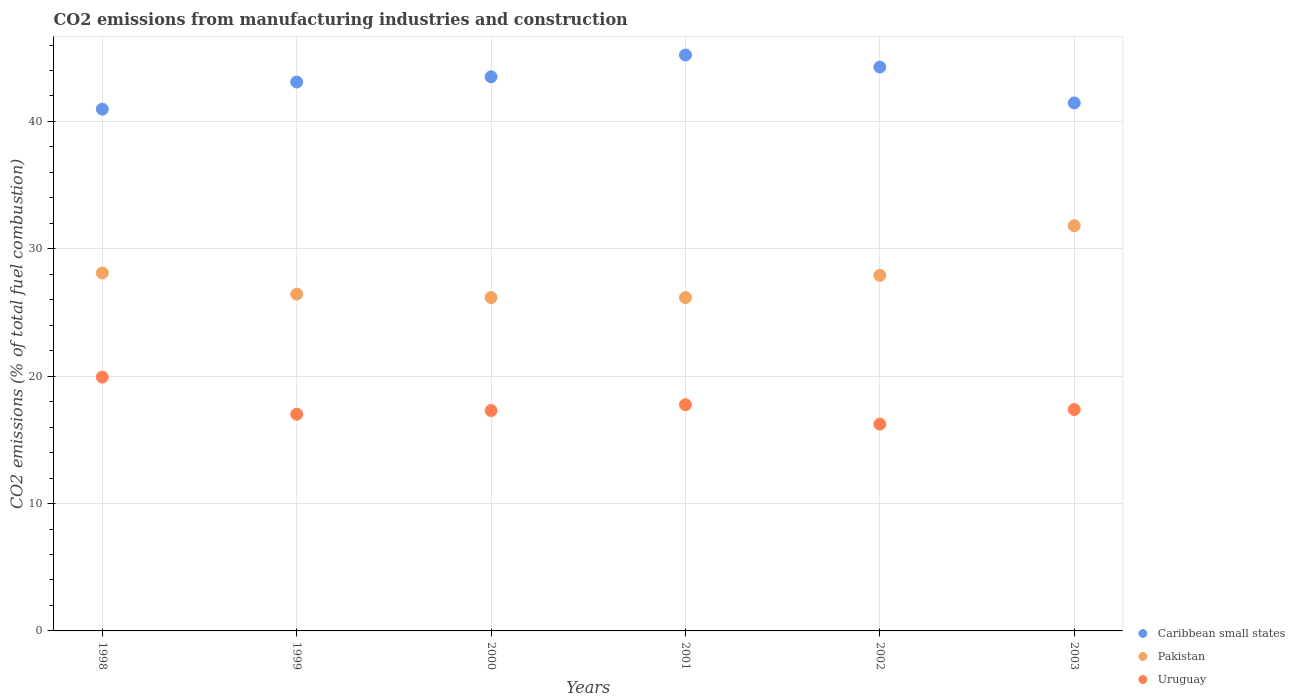Is the number of dotlines equal to the number of legend labels?
Offer a terse response. Yes. What is the amount of CO2 emitted in Caribbean small states in 2001?
Keep it short and to the point. 45.21. Across all years, what is the maximum amount of CO2 emitted in Uruguay?
Your response must be concise. 19.93. Across all years, what is the minimum amount of CO2 emitted in Caribbean small states?
Your answer should be compact. 40.97. What is the total amount of CO2 emitted in Uruguay in the graph?
Keep it short and to the point. 105.62. What is the difference between the amount of CO2 emitted in Uruguay in 2000 and that in 2001?
Your answer should be very brief. -0.46. What is the difference between the amount of CO2 emitted in Pakistan in 2002 and the amount of CO2 emitted in Uruguay in 2000?
Make the answer very short. 10.61. What is the average amount of CO2 emitted in Pakistan per year?
Make the answer very short. 27.77. In the year 2001, what is the difference between the amount of CO2 emitted in Uruguay and amount of CO2 emitted in Pakistan?
Your response must be concise. -8.41. What is the ratio of the amount of CO2 emitted in Pakistan in 1998 to that in 2000?
Ensure brevity in your answer.  1.07. Is the difference between the amount of CO2 emitted in Uruguay in 1999 and 2002 greater than the difference between the amount of CO2 emitted in Pakistan in 1999 and 2002?
Your answer should be compact. Yes. What is the difference between the highest and the second highest amount of CO2 emitted in Pakistan?
Provide a short and direct response. 3.71. What is the difference between the highest and the lowest amount of CO2 emitted in Uruguay?
Keep it short and to the point. 3.69. Is the sum of the amount of CO2 emitted in Pakistan in 1998 and 2001 greater than the maximum amount of CO2 emitted in Uruguay across all years?
Your answer should be very brief. Yes. Is it the case that in every year, the sum of the amount of CO2 emitted in Caribbean small states and amount of CO2 emitted in Uruguay  is greater than the amount of CO2 emitted in Pakistan?
Offer a terse response. Yes. Does the amount of CO2 emitted in Uruguay monotonically increase over the years?
Provide a short and direct response. No. Is the amount of CO2 emitted in Caribbean small states strictly greater than the amount of CO2 emitted in Pakistan over the years?
Give a very brief answer. Yes. How many dotlines are there?
Your answer should be compact. 3. How many years are there in the graph?
Give a very brief answer. 6. Does the graph contain any zero values?
Ensure brevity in your answer.  No. Does the graph contain grids?
Provide a short and direct response. Yes. Where does the legend appear in the graph?
Make the answer very short. Bottom right. How many legend labels are there?
Your response must be concise. 3. How are the legend labels stacked?
Make the answer very short. Vertical. What is the title of the graph?
Provide a short and direct response. CO2 emissions from manufacturing industries and construction. Does "Palau" appear as one of the legend labels in the graph?
Provide a short and direct response. No. What is the label or title of the Y-axis?
Provide a short and direct response. CO2 emissions (% of total fuel combustion). What is the CO2 emissions (% of total fuel combustion) in Caribbean small states in 1998?
Offer a terse response. 40.97. What is the CO2 emissions (% of total fuel combustion) in Pakistan in 1998?
Keep it short and to the point. 28.1. What is the CO2 emissions (% of total fuel combustion) in Uruguay in 1998?
Give a very brief answer. 19.93. What is the CO2 emissions (% of total fuel combustion) in Caribbean small states in 1999?
Make the answer very short. 43.1. What is the CO2 emissions (% of total fuel combustion) of Pakistan in 1999?
Your answer should be very brief. 26.44. What is the CO2 emissions (% of total fuel combustion) of Uruguay in 1999?
Provide a short and direct response. 17.01. What is the CO2 emissions (% of total fuel combustion) in Caribbean small states in 2000?
Keep it short and to the point. 43.5. What is the CO2 emissions (% of total fuel combustion) of Pakistan in 2000?
Provide a succinct answer. 26.17. What is the CO2 emissions (% of total fuel combustion) of Uruguay in 2000?
Your response must be concise. 17.3. What is the CO2 emissions (% of total fuel combustion) of Caribbean small states in 2001?
Your answer should be compact. 45.21. What is the CO2 emissions (% of total fuel combustion) of Pakistan in 2001?
Your response must be concise. 26.17. What is the CO2 emissions (% of total fuel combustion) of Uruguay in 2001?
Give a very brief answer. 17.76. What is the CO2 emissions (% of total fuel combustion) in Caribbean small states in 2002?
Make the answer very short. 44.27. What is the CO2 emissions (% of total fuel combustion) in Pakistan in 2002?
Offer a terse response. 27.91. What is the CO2 emissions (% of total fuel combustion) in Uruguay in 2002?
Provide a short and direct response. 16.24. What is the CO2 emissions (% of total fuel combustion) in Caribbean small states in 2003?
Offer a terse response. 41.45. What is the CO2 emissions (% of total fuel combustion) in Pakistan in 2003?
Your response must be concise. 31.81. What is the CO2 emissions (% of total fuel combustion) in Uruguay in 2003?
Give a very brief answer. 17.38. Across all years, what is the maximum CO2 emissions (% of total fuel combustion) of Caribbean small states?
Your response must be concise. 45.21. Across all years, what is the maximum CO2 emissions (% of total fuel combustion) of Pakistan?
Your answer should be compact. 31.81. Across all years, what is the maximum CO2 emissions (% of total fuel combustion) in Uruguay?
Give a very brief answer. 19.93. Across all years, what is the minimum CO2 emissions (% of total fuel combustion) in Caribbean small states?
Offer a very short reply. 40.97. Across all years, what is the minimum CO2 emissions (% of total fuel combustion) of Pakistan?
Give a very brief answer. 26.17. Across all years, what is the minimum CO2 emissions (% of total fuel combustion) of Uruguay?
Your answer should be compact. 16.24. What is the total CO2 emissions (% of total fuel combustion) of Caribbean small states in the graph?
Give a very brief answer. 258.5. What is the total CO2 emissions (% of total fuel combustion) in Pakistan in the graph?
Your answer should be compact. 166.62. What is the total CO2 emissions (% of total fuel combustion) of Uruguay in the graph?
Provide a succinct answer. 105.62. What is the difference between the CO2 emissions (% of total fuel combustion) in Caribbean small states in 1998 and that in 1999?
Ensure brevity in your answer.  -2.13. What is the difference between the CO2 emissions (% of total fuel combustion) of Pakistan in 1998 and that in 1999?
Provide a short and direct response. 1.66. What is the difference between the CO2 emissions (% of total fuel combustion) in Uruguay in 1998 and that in 1999?
Offer a terse response. 2.91. What is the difference between the CO2 emissions (% of total fuel combustion) of Caribbean small states in 1998 and that in 2000?
Your answer should be very brief. -2.54. What is the difference between the CO2 emissions (% of total fuel combustion) in Pakistan in 1998 and that in 2000?
Provide a short and direct response. 1.93. What is the difference between the CO2 emissions (% of total fuel combustion) in Uruguay in 1998 and that in 2000?
Provide a succinct answer. 2.63. What is the difference between the CO2 emissions (% of total fuel combustion) of Caribbean small states in 1998 and that in 2001?
Your response must be concise. -4.25. What is the difference between the CO2 emissions (% of total fuel combustion) of Pakistan in 1998 and that in 2001?
Ensure brevity in your answer.  1.93. What is the difference between the CO2 emissions (% of total fuel combustion) in Uruguay in 1998 and that in 2001?
Give a very brief answer. 2.17. What is the difference between the CO2 emissions (% of total fuel combustion) in Caribbean small states in 1998 and that in 2002?
Keep it short and to the point. -3.31. What is the difference between the CO2 emissions (% of total fuel combustion) in Pakistan in 1998 and that in 2002?
Your answer should be compact. 0.19. What is the difference between the CO2 emissions (% of total fuel combustion) of Uruguay in 1998 and that in 2002?
Your answer should be compact. 3.69. What is the difference between the CO2 emissions (% of total fuel combustion) in Caribbean small states in 1998 and that in 2003?
Provide a succinct answer. -0.49. What is the difference between the CO2 emissions (% of total fuel combustion) of Pakistan in 1998 and that in 2003?
Make the answer very short. -3.71. What is the difference between the CO2 emissions (% of total fuel combustion) in Uruguay in 1998 and that in 2003?
Make the answer very short. 2.55. What is the difference between the CO2 emissions (% of total fuel combustion) in Caribbean small states in 1999 and that in 2000?
Provide a succinct answer. -0.41. What is the difference between the CO2 emissions (% of total fuel combustion) in Pakistan in 1999 and that in 2000?
Offer a terse response. 0.27. What is the difference between the CO2 emissions (% of total fuel combustion) in Uruguay in 1999 and that in 2000?
Keep it short and to the point. -0.29. What is the difference between the CO2 emissions (% of total fuel combustion) of Caribbean small states in 1999 and that in 2001?
Provide a succinct answer. -2.12. What is the difference between the CO2 emissions (% of total fuel combustion) in Pakistan in 1999 and that in 2001?
Give a very brief answer. 0.27. What is the difference between the CO2 emissions (% of total fuel combustion) in Uruguay in 1999 and that in 2001?
Offer a very short reply. -0.74. What is the difference between the CO2 emissions (% of total fuel combustion) in Caribbean small states in 1999 and that in 2002?
Your answer should be very brief. -1.18. What is the difference between the CO2 emissions (% of total fuel combustion) in Pakistan in 1999 and that in 2002?
Your answer should be compact. -1.47. What is the difference between the CO2 emissions (% of total fuel combustion) in Uruguay in 1999 and that in 2002?
Your answer should be compact. 0.78. What is the difference between the CO2 emissions (% of total fuel combustion) of Caribbean small states in 1999 and that in 2003?
Your response must be concise. 1.64. What is the difference between the CO2 emissions (% of total fuel combustion) of Pakistan in 1999 and that in 2003?
Keep it short and to the point. -5.37. What is the difference between the CO2 emissions (% of total fuel combustion) in Uruguay in 1999 and that in 2003?
Offer a very short reply. -0.37. What is the difference between the CO2 emissions (% of total fuel combustion) in Caribbean small states in 2000 and that in 2001?
Your answer should be very brief. -1.71. What is the difference between the CO2 emissions (% of total fuel combustion) of Pakistan in 2000 and that in 2001?
Give a very brief answer. -0. What is the difference between the CO2 emissions (% of total fuel combustion) in Uruguay in 2000 and that in 2001?
Offer a very short reply. -0.46. What is the difference between the CO2 emissions (% of total fuel combustion) of Caribbean small states in 2000 and that in 2002?
Keep it short and to the point. -0.77. What is the difference between the CO2 emissions (% of total fuel combustion) of Pakistan in 2000 and that in 2002?
Provide a succinct answer. -1.74. What is the difference between the CO2 emissions (% of total fuel combustion) of Uruguay in 2000 and that in 2002?
Offer a very short reply. 1.07. What is the difference between the CO2 emissions (% of total fuel combustion) of Caribbean small states in 2000 and that in 2003?
Ensure brevity in your answer.  2.05. What is the difference between the CO2 emissions (% of total fuel combustion) in Pakistan in 2000 and that in 2003?
Give a very brief answer. -5.64. What is the difference between the CO2 emissions (% of total fuel combustion) in Uruguay in 2000 and that in 2003?
Your answer should be compact. -0.08. What is the difference between the CO2 emissions (% of total fuel combustion) of Caribbean small states in 2001 and that in 2002?
Make the answer very short. 0.94. What is the difference between the CO2 emissions (% of total fuel combustion) in Pakistan in 2001 and that in 2002?
Keep it short and to the point. -1.74. What is the difference between the CO2 emissions (% of total fuel combustion) of Uruguay in 2001 and that in 2002?
Keep it short and to the point. 1.52. What is the difference between the CO2 emissions (% of total fuel combustion) in Caribbean small states in 2001 and that in 2003?
Your answer should be compact. 3.76. What is the difference between the CO2 emissions (% of total fuel combustion) of Pakistan in 2001 and that in 2003?
Give a very brief answer. -5.64. What is the difference between the CO2 emissions (% of total fuel combustion) in Uruguay in 2001 and that in 2003?
Make the answer very short. 0.38. What is the difference between the CO2 emissions (% of total fuel combustion) of Caribbean small states in 2002 and that in 2003?
Your response must be concise. 2.82. What is the difference between the CO2 emissions (% of total fuel combustion) in Pakistan in 2002 and that in 2003?
Offer a very short reply. -3.9. What is the difference between the CO2 emissions (% of total fuel combustion) of Uruguay in 2002 and that in 2003?
Ensure brevity in your answer.  -1.15. What is the difference between the CO2 emissions (% of total fuel combustion) in Caribbean small states in 1998 and the CO2 emissions (% of total fuel combustion) in Pakistan in 1999?
Make the answer very short. 14.52. What is the difference between the CO2 emissions (% of total fuel combustion) of Caribbean small states in 1998 and the CO2 emissions (% of total fuel combustion) of Uruguay in 1999?
Keep it short and to the point. 23.95. What is the difference between the CO2 emissions (% of total fuel combustion) in Pakistan in 1998 and the CO2 emissions (% of total fuel combustion) in Uruguay in 1999?
Provide a succinct answer. 11.09. What is the difference between the CO2 emissions (% of total fuel combustion) of Caribbean small states in 1998 and the CO2 emissions (% of total fuel combustion) of Pakistan in 2000?
Keep it short and to the point. 14.79. What is the difference between the CO2 emissions (% of total fuel combustion) in Caribbean small states in 1998 and the CO2 emissions (% of total fuel combustion) in Uruguay in 2000?
Offer a very short reply. 23.66. What is the difference between the CO2 emissions (% of total fuel combustion) of Pakistan in 1998 and the CO2 emissions (% of total fuel combustion) of Uruguay in 2000?
Your answer should be very brief. 10.8. What is the difference between the CO2 emissions (% of total fuel combustion) of Caribbean small states in 1998 and the CO2 emissions (% of total fuel combustion) of Pakistan in 2001?
Provide a succinct answer. 14.79. What is the difference between the CO2 emissions (% of total fuel combustion) of Caribbean small states in 1998 and the CO2 emissions (% of total fuel combustion) of Uruguay in 2001?
Your response must be concise. 23.21. What is the difference between the CO2 emissions (% of total fuel combustion) in Pakistan in 1998 and the CO2 emissions (% of total fuel combustion) in Uruguay in 2001?
Offer a terse response. 10.34. What is the difference between the CO2 emissions (% of total fuel combustion) in Caribbean small states in 1998 and the CO2 emissions (% of total fuel combustion) in Pakistan in 2002?
Your answer should be compact. 13.05. What is the difference between the CO2 emissions (% of total fuel combustion) of Caribbean small states in 1998 and the CO2 emissions (% of total fuel combustion) of Uruguay in 2002?
Provide a succinct answer. 24.73. What is the difference between the CO2 emissions (% of total fuel combustion) in Pakistan in 1998 and the CO2 emissions (% of total fuel combustion) in Uruguay in 2002?
Offer a very short reply. 11.87. What is the difference between the CO2 emissions (% of total fuel combustion) of Caribbean small states in 1998 and the CO2 emissions (% of total fuel combustion) of Pakistan in 2003?
Ensure brevity in your answer.  9.15. What is the difference between the CO2 emissions (% of total fuel combustion) in Caribbean small states in 1998 and the CO2 emissions (% of total fuel combustion) in Uruguay in 2003?
Your answer should be very brief. 23.58. What is the difference between the CO2 emissions (% of total fuel combustion) in Pakistan in 1998 and the CO2 emissions (% of total fuel combustion) in Uruguay in 2003?
Ensure brevity in your answer.  10.72. What is the difference between the CO2 emissions (% of total fuel combustion) of Caribbean small states in 1999 and the CO2 emissions (% of total fuel combustion) of Pakistan in 2000?
Your answer should be compact. 16.92. What is the difference between the CO2 emissions (% of total fuel combustion) of Caribbean small states in 1999 and the CO2 emissions (% of total fuel combustion) of Uruguay in 2000?
Keep it short and to the point. 25.79. What is the difference between the CO2 emissions (% of total fuel combustion) of Pakistan in 1999 and the CO2 emissions (% of total fuel combustion) of Uruguay in 2000?
Provide a short and direct response. 9.14. What is the difference between the CO2 emissions (% of total fuel combustion) in Caribbean small states in 1999 and the CO2 emissions (% of total fuel combustion) in Pakistan in 2001?
Make the answer very short. 16.92. What is the difference between the CO2 emissions (% of total fuel combustion) in Caribbean small states in 1999 and the CO2 emissions (% of total fuel combustion) in Uruguay in 2001?
Give a very brief answer. 25.34. What is the difference between the CO2 emissions (% of total fuel combustion) in Pakistan in 1999 and the CO2 emissions (% of total fuel combustion) in Uruguay in 2001?
Your response must be concise. 8.69. What is the difference between the CO2 emissions (% of total fuel combustion) of Caribbean small states in 1999 and the CO2 emissions (% of total fuel combustion) of Pakistan in 2002?
Provide a succinct answer. 15.18. What is the difference between the CO2 emissions (% of total fuel combustion) in Caribbean small states in 1999 and the CO2 emissions (% of total fuel combustion) in Uruguay in 2002?
Offer a terse response. 26.86. What is the difference between the CO2 emissions (% of total fuel combustion) of Pakistan in 1999 and the CO2 emissions (% of total fuel combustion) of Uruguay in 2002?
Offer a very short reply. 10.21. What is the difference between the CO2 emissions (% of total fuel combustion) in Caribbean small states in 1999 and the CO2 emissions (% of total fuel combustion) in Pakistan in 2003?
Provide a succinct answer. 11.28. What is the difference between the CO2 emissions (% of total fuel combustion) of Caribbean small states in 1999 and the CO2 emissions (% of total fuel combustion) of Uruguay in 2003?
Your answer should be compact. 25.71. What is the difference between the CO2 emissions (% of total fuel combustion) in Pakistan in 1999 and the CO2 emissions (% of total fuel combustion) in Uruguay in 2003?
Ensure brevity in your answer.  9.06. What is the difference between the CO2 emissions (% of total fuel combustion) in Caribbean small states in 2000 and the CO2 emissions (% of total fuel combustion) in Pakistan in 2001?
Give a very brief answer. 17.33. What is the difference between the CO2 emissions (% of total fuel combustion) of Caribbean small states in 2000 and the CO2 emissions (% of total fuel combustion) of Uruguay in 2001?
Offer a terse response. 25.74. What is the difference between the CO2 emissions (% of total fuel combustion) in Pakistan in 2000 and the CO2 emissions (% of total fuel combustion) in Uruguay in 2001?
Your answer should be very brief. 8.41. What is the difference between the CO2 emissions (% of total fuel combustion) in Caribbean small states in 2000 and the CO2 emissions (% of total fuel combustion) in Pakistan in 2002?
Your answer should be compact. 15.59. What is the difference between the CO2 emissions (% of total fuel combustion) of Caribbean small states in 2000 and the CO2 emissions (% of total fuel combustion) of Uruguay in 2002?
Ensure brevity in your answer.  27.27. What is the difference between the CO2 emissions (% of total fuel combustion) in Pakistan in 2000 and the CO2 emissions (% of total fuel combustion) in Uruguay in 2002?
Keep it short and to the point. 9.94. What is the difference between the CO2 emissions (% of total fuel combustion) in Caribbean small states in 2000 and the CO2 emissions (% of total fuel combustion) in Pakistan in 2003?
Ensure brevity in your answer.  11.69. What is the difference between the CO2 emissions (% of total fuel combustion) of Caribbean small states in 2000 and the CO2 emissions (% of total fuel combustion) of Uruguay in 2003?
Give a very brief answer. 26.12. What is the difference between the CO2 emissions (% of total fuel combustion) in Pakistan in 2000 and the CO2 emissions (% of total fuel combustion) in Uruguay in 2003?
Offer a very short reply. 8.79. What is the difference between the CO2 emissions (% of total fuel combustion) of Caribbean small states in 2001 and the CO2 emissions (% of total fuel combustion) of Uruguay in 2002?
Keep it short and to the point. 28.98. What is the difference between the CO2 emissions (% of total fuel combustion) in Pakistan in 2001 and the CO2 emissions (% of total fuel combustion) in Uruguay in 2002?
Offer a very short reply. 9.94. What is the difference between the CO2 emissions (% of total fuel combustion) of Caribbean small states in 2001 and the CO2 emissions (% of total fuel combustion) of Pakistan in 2003?
Provide a short and direct response. 13.4. What is the difference between the CO2 emissions (% of total fuel combustion) of Caribbean small states in 2001 and the CO2 emissions (% of total fuel combustion) of Uruguay in 2003?
Provide a succinct answer. 27.83. What is the difference between the CO2 emissions (% of total fuel combustion) of Pakistan in 2001 and the CO2 emissions (% of total fuel combustion) of Uruguay in 2003?
Provide a short and direct response. 8.79. What is the difference between the CO2 emissions (% of total fuel combustion) in Caribbean small states in 2002 and the CO2 emissions (% of total fuel combustion) in Pakistan in 2003?
Offer a terse response. 12.46. What is the difference between the CO2 emissions (% of total fuel combustion) of Caribbean small states in 2002 and the CO2 emissions (% of total fuel combustion) of Uruguay in 2003?
Your answer should be very brief. 26.89. What is the difference between the CO2 emissions (% of total fuel combustion) of Pakistan in 2002 and the CO2 emissions (% of total fuel combustion) of Uruguay in 2003?
Your answer should be compact. 10.53. What is the average CO2 emissions (% of total fuel combustion) of Caribbean small states per year?
Give a very brief answer. 43.08. What is the average CO2 emissions (% of total fuel combustion) of Pakistan per year?
Your answer should be compact. 27.77. What is the average CO2 emissions (% of total fuel combustion) of Uruguay per year?
Give a very brief answer. 17.6. In the year 1998, what is the difference between the CO2 emissions (% of total fuel combustion) of Caribbean small states and CO2 emissions (% of total fuel combustion) of Pakistan?
Make the answer very short. 12.86. In the year 1998, what is the difference between the CO2 emissions (% of total fuel combustion) of Caribbean small states and CO2 emissions (% of total fuel combustion) of Uruguay?
Offer a very short reply. 21.04. In the year 1998, what is the difference between the CO2 emissions (% of total fuel combustion) in Pakistan and CO2 emissions (% of total fuel combustion) in Uruguay?
Your response must be concise. 8.17. In the year 1999, what is the difference between the CO2 emissions (% of total fuel combustion) of Caribbean small states and CO2 emissions (% of total fuel combustion) of Pakistan?
Your response must be concise. 16.65. In the year 1999, what is the difference between the CO2 emissions (% of total fuel combustion) of Caribbean small states and CO2 emissions (% of total fuel combustion) of Uruguay?
Provide a succinct answer. 26.08. In the year 1999, what is the difference between the CO2 emissions (% of total fuel combustion) in Pakistan and CO2 emissions (% of total fuel combustion) in Uruguay?
Give a very brief answer. 9.43. In the year 2000, what is the difference between the CO2 emissions (% of total fuel combustion) of Caribbean small states and CO2 emissions (% of total fuel combustion) of Pakistan?
Your answer should be very brief. 17.33. In the year 2000, what is the difference between the CO2 emissions (% of total fuel combustion) in Caribbean small states and CO2 emissions (% of total fuel combustion) in Uruguay?
Offer a terse response. 26.2. In the year 2000, what is the difference between the CO2 emissions (% of total fuel combustion) in Pakistan and CO2 emissions (% of total fuel combustion) in Uruguay?
Your answer should be compact. 8.87. In the year 2001, what is the difference between the CO2 emissions (% of total fuel combustion) in Caribbean small states and CO2 emissions (% of total fuel combustion) in Pakistan?
Keep it short and to the point. 19.04. In the year 2001, what is the difference between the CO2 emissions (% of total fuel combustion) of Caribbean small states and CO2 emissions (% of total fuel combustion) of Uruguay?
Make the answer very short. 27.45. In the year 2001, what is the difference between the CO2 emissions (% of total fuel combustion) in Pakistan and CO2 emissions (% of total fuel combustion) in Uruguay?
Your answer should be very brief. 8.41. In the year 2002, what is the difference between the CO2 emissions (% of total fuel combustion) of Caribbean small states and CO2 emissions (% of total fuel combustion) of Pakistan?
Provide a short and direct response. 16.36. In the year 2002, what is the difference between the CO2 emissions (% of total fuel combustion) of Caribbean small states and CO2 emissions (% of total fuel combustion) of Uruguay?
Ensure brevity in your answer.  28.04. In the year 2002, what is the difference between the CO2 emissions (% of total fuel combustion) in Pakistan and CO2 emissions (% of total fuel combustion) in Uruguay?
Provide a succinct answer. 11.68. In the year 2003, what is the difference between the CO2 emissions (% of total fuel combustion) of Caribbean small states and CO2 emissions (% of total fuel combustion) of Pakistan?
Keep it short and to the point. 9.64. In the year 2003, what is the difference between the CO2 emissions (% of total fuel combustion) in Caribbean small states and CO2 emissions (% of total fuel combustion) in Uruguay?
Offer a very short reply. 24.07. In the year 2003, what is the difference between the CO2 emissions (% of total fuel combustion) in Pakistan and CO2 emissions (% of total fuel combustion) in Uruguay?
Your answer should be very brief. 14.43. What is the ratio of the CO2 emissions (% of total fuel combustion) of Caribbean small states in 1998 to that in 1999?
Give a very brief answer. 0.95. What is the ratio of the CO2 emissions (% of total fuel combustion) of Pakistan in 1998 to that in 1999?
Keep it short and to the point. 1.06. What is the ratio of the CO2 emissions (% of total fuel combustion) of Uruguay in 1998 to that in 1999?
Offer a very short reply. 1.17. What is the ratio of the CO2 emissions (% of total fuel combustion) in Caribbean small states in 1998 to that in 2000?
Offer a very short reply. 0.94. What is the ratio of the CO2 emissions (% of total fuel combustion) in Pakistan in 1998 to that in 2000?
Ensure brevity in your answer.  1.07. What is the ratio of the CO2 emissions (% of total fuel combustion) of Uruguay in 1998 to that in 2000?
Keep it short and to the point. 1.15. What is the ratio of the CO2 emissions (% of total fuel combustion) of Caribbean small states in 1998 to that in 2001?
Keep it short and to the point. 0.91. What is the ratio of the CO2 emissions (% of total fuel combustion) in Pakistan in 1998 to that in 2001?
Your response must be concise. 1.07. What is the ratio of the CO2 emissions (% of total fuel combustion) of Uruguay in 1998 to that in 2001?
Keep it short and to the point. 1.12. What is the ratio of the CO2 emissions (% of total fuel combustion) in Caribbean small states in 1998 to that in 2002?
Give a very brief answer. 0.93. What is the ratio of the CO2 emissions (% of total fuel combustion) in Pakistan in 1998 to that in 2002?
Offer a terse response. 1.01. What is the ratio of the CO2 emissions (% of total fuel combustion) in Uruguay in 1998 to that in 2002?
Make the answer very short. 1.23. What is the ratio of the CO2 emissions (% of total fuel combustion) of Pakistan in 1998 to that in 2003?
Offer a very short reply. 0.88. What is the ratio of the CO2 emissions (% of total fuel combustion) in Uruguay in 1998 to that in 2003?
Give a very brief answer. 1.15. What is the ratio of the CO2 emissions (% of total fuel combustion) in Pakistan in 1999 to that in 2000?
Keep it short and to the point. 1.01. What is the ratio of the CO2 emissions (% of total fuel combustion) in Uruguay in 1999 to that in 2000?
Provide a short and direct response. 0.98. What is the ratio of the CO2 emissions (% of total fuel combustion) of Caribbean small states in 1999 to that in 2001?
Your answer should be compact. 0.95. What is the ratio of the CO2 emissions (% of total fuel combustion) of Pakistan in 1999 to that in 2001?
Offer a terse response. 1.01. What is the ratio of the CO2 emissions (% of total fuel combustion) in Uruguay in 1999 to that in 2001?
Ensure brevity in your answer.  0.96. What is the ratio of the CO2 emissions (% of total fuel combustion) in Caribbean small states in 1999 to that in 2002?
Make the answer very short. 0.97. What is the ratio of the CO2 emissions (% of total fuel combustion) of Pakistan in 1999 to that in 2002?
Provide a short and direct response. 0.95. What is the ratio of the CO2 emissions (% of total fuel combustion) of Uruguay in 1999 to that in 2002?
Keep it short and to the point. 1.05. What is the ratio of the CO2 emissions (% of total fuel combustion) of Caribbean small states in 1999 to that in 2003?
Your answer should be very brief. 1.04. What is the ratio of the CO2 emissions (% of total fuel combustion) of Pakistan in 1999 to that in 2003?
Your answer should be very brief. 0.83. What is the ratio of the CO2 emissions (% of total fuel combustion) in Uruguay in 1999 to that in 2003?
Your answer should be very brief. 0.98. What is the ratio of the CO2 emissions (% of total fuel combustion) of Caribbean small states in 2000 to that in 2001?
Offer a very short reply. 0.96. What is the ratio of the CO2 emissions (% of total fuel combustion) in Pakistan in 2000 to that in 2001?
Your answer should be very brief. 1. What is the ratio of the CO2 emissions (% of total fuel combustion) of Uruguay in 2000 to that in 2001?
Provide a succinct answer. 0.97. What is the ratio of the CO2 emissions (% of total fuel combustion) in Caribbean small states in 2000 to that in 2002?
Your answer should be compact. 0.98. What is the ratio of the CO2 emissions (% of total fuel combustion) in Pakistan in 2000 to that in 2002?
Your response must be concise. 0.94. What is the ratio of the CO2 emissions (% of total fuel combustion) of Uruguay in 2000 to that in 2002?
Offer a terse response. 1.07. What is the ratio of the CO2 emissions (% of total fuel combustion) of Caribbean small states in 2000 to that in 2003?
Keep it short and to the point. 1.05. What is the ratio of the CO2 emissions (% of total fuel combustion) of Pakistan in 2000 to that in 2003?
Give a very brief answer. 0.82. What is the ratio of the CO2 emissions (% of total fuel combustion) in Uruguay in 2000 to that in 2003?
Your response must be concise. 1. What is the ratio of the CO2 emissions (% of total fuel combustion) in Caribbean small states in 2001 to that in 2002?
Offer a very short reply. 1.02. What is the ratio of the CO2 emissions (% of total fuel combustion) in Pakistan in 2001 to that in 2002?
Your answer should be very brief. 0.94. What is the ratio of the CO2 emissions (% of total fuel combustion) in Uruguay in 2001 to that in 2002?
Make the answer very short. 1.09. What is the ratio of the CO2 emissions (% of total fuel combustion) of Caribbean small states in 2001 to that in 2003?
Your answer should be compact. 1.09. What is the ratio of the CO2 emissions (% of total fuel combustion) of Pakistan in 2001 to that in 2003?
Give a very brief answer. 0.82. What is the ratio of the CO2 emissions (% of total fuel combustion) in Uruguay in 2001 to that in 2003?
Offer a very short reply. 1.02. What is the ratio of the CO2 emissions (% of total fuel combustion) in Caribbean small states in 2002 to that in 2003?
Make the answer very short. 1.07. What is the ratio of the CO2 emissions (% of total fuel combustion) of Pakistan in 2002 to that in 2003?
Ensure brevity in your answer.  0.88. What is the ratio of the CO2 emissions (% of total fuel combustion) in Uruguay in 2002 to that in 2003?
Give a very brief answer. 0.93. What is the difference between the highest and the second highest CO2 emissions (% of total fuel combustion) of Caribbean small states?
Your response must be concise. 0.94. What is the difference between the highest and the second highest CO2 emissions (% of total fuel combustion) of Pakistan?
Provide a short and direct response. 3.71. What is the difference between the highest and the second highest CO2 emissions (% of total fuel combustion) of Uruguay?
Offer a very short reply. 2.17. What is the difference between the highest and the lowest CO2 emissions (% of total fuel combustion) in Caribbean small states?
Your answer should be compact. 4.25. What is the difference between the highest and the lowest CO2 emissions (% of total fuel combustion) of Pakistan?
Offer a terse response. 5.64. What is the difference between the highest and the lowest CO2 emissions (% of total fuel combustion) of Uruguay?
Your response must be concise. 3.69. 